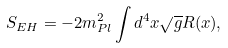Convert formula to latex. <formula><loc_0><loc_0><loc_500><loc_500>S _ { E H } = - 2 m ^ { 2 } _ { P l } \int d ^ { 4 } x \sqrt { g } R ( x ) ,</formula> 